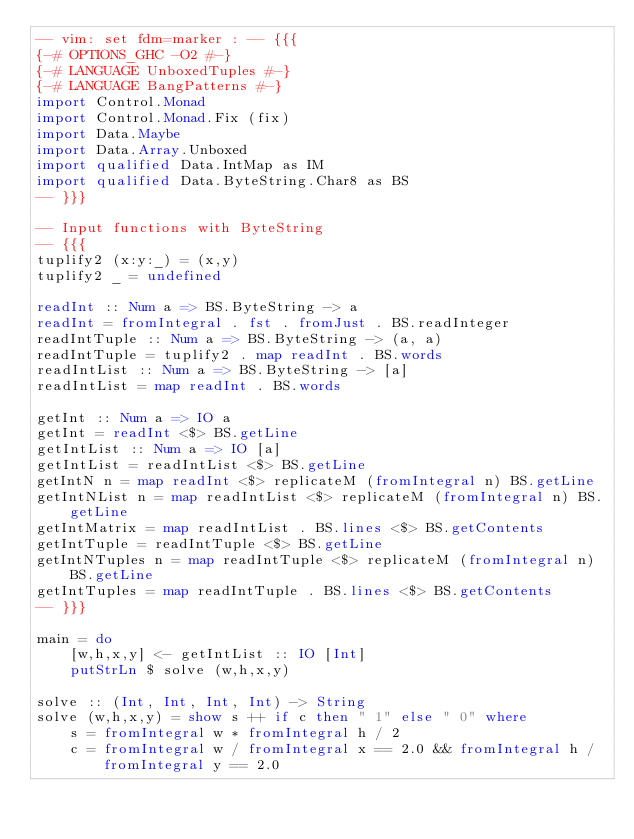Convert code to text. <code><loc_0><loc_0><loc_500><loc_500><_Haskell_>-- vim: set fdm=marker : -- {{{
{-# OPTIONS_GHC -O2 #-}
{-# LANGUAGE UnboxedTuples #-}
{-# LANGUAGE BangPatterns #-}
import Control.Monad
import Control.Monad.Fix (fix)
import Data.Maybe
import Data.Array.Unboxed
import qualified Data.IntMap as IM
import qualified Data.ByteString.Char8 as BS
-- }}}

-- Input functions with ByteString
-- {{{
tuplify2 (x:y:_) = (x,y)
tuplify2 _ = undefined

readInt :: Num a => BS.ByteString -> a
readInt = fromIntegral . fst . fromJust . BS.readInteger
readIntTuple :: Num a => BS.ByteString -> (a, a)
readIntTuple = tuplify2 . map readInt . BS.words
readIntList :: Num a => BS.ByteString -> [a]
readIntList = map readInt . BS.words

getInt :: Num a => IO a
getInt = readInt <$> BS.getLine
getIntList :: Num a => IO [a]
getIntList = readIntList <$> BS.getLine
getIntN n = map readInt <$> replicateM (fromIntegral n) BS.getLine
getIntNList n = map readIntList <$> replicateM (fromIntegral n) BS.getLine
getIntMatrix = map readIntList . BS.lines <$> BS.getContents
getIntTuple = readIntTuple <$> BS.getLine
getIntNTuples n = map readIntTuple <$> replicateM (fromIntegral n) BS.getLine
getIntTuples = map readIntTuple . BS.lines <$> BS.getContents
-- }}}

main = do
    [w,h,x,y] <- getIntList :: IO [Int]
    putStrLn $ solve (w,h,x,y)

solve :: (Int, Int, Int, Int) -> String
solve (w,h,x,y) = show s ++ if c then " 1" else " 0" where
    s = fromIntegral w * fromIntegral h / 2
    c = fromIntegral w / fromIntegral x == 2.0 && fromIntegral h / fromIntegral y == 2.0
</code> 